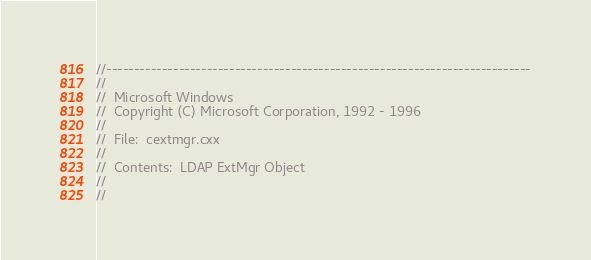<code> <loc_0><loc_0><loc_500><loc_500><_C++_>//----------------------------------------------------------------------------
//
//  Microsoft Windows
//  Copyright (C) Microsoft Corporation, 1992 - 1996
//
//  File:  cextmgr.cxx
//
//  Contents:  LDAP ExtMgr Object
//
//</code> 